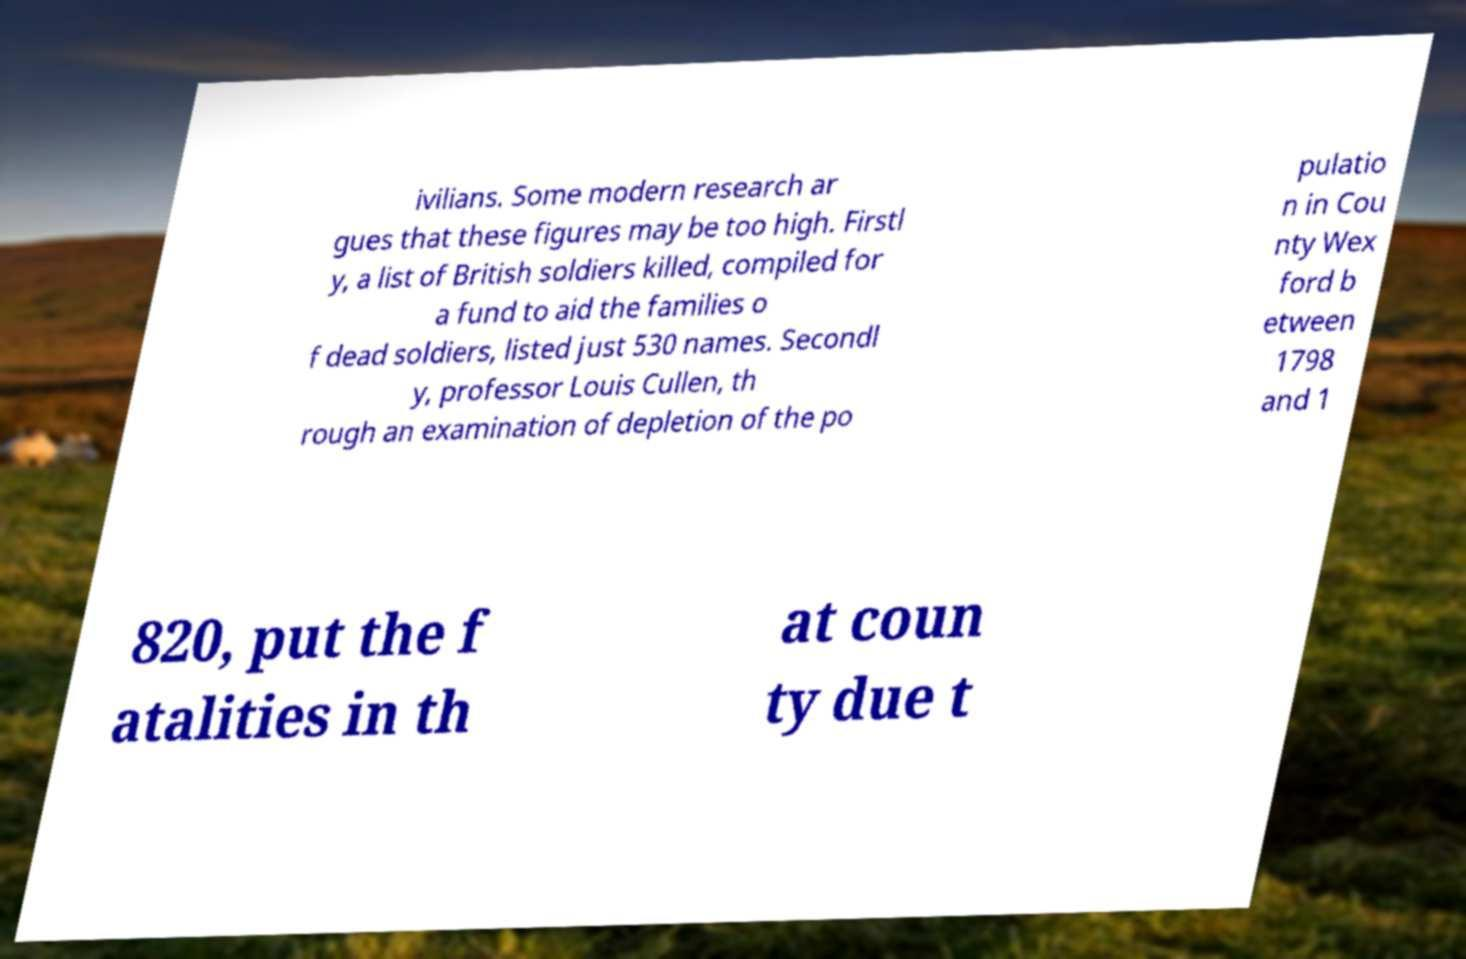I need the written content from this picture converted into text. Can you do that? ivilians. Some modern research ar gues that these figures may be too high. Firstl y, a list of British soldiers killed, compiled for a fund to aid the families o f dead soldiers, listed just 530 names. Secondl y, professor Louis Cullen, th rough an examination of depletion of the po pulatio n in Cou nty Wex ford b etween 1798 and 1 820, put the f atalities in th at coun ty due t 